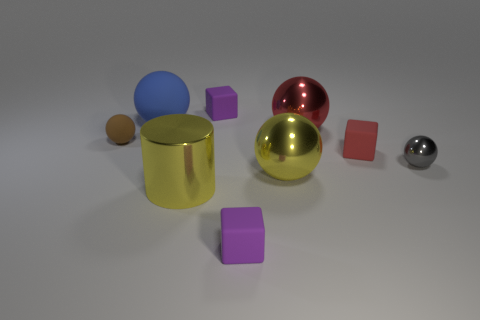Is there a tiny cyan cylinder?
Keep it short and to the point. No. How many other things are there of the same shape as the red metal thing?
Your answer should be very brief. 4. Is the color of the large thing that is on the left side of the big yellow cylinder the same as the block behind the tiny rubber sphere?
Your answer should be compact. No. There is a purple block behind the purple rubber object that is in front of the tiny gray ball behind the big yellow metal cylinder; how big is it?
Keep it short and to the point. Small. What shape is the thing that is both behind the small red matte cube and in front of the large red sphere?
Your response must be concise. Sphere. Are there an equal number of red blocks in front of the tiny brown thing and small brown balls in front of the big yellow shiny cylinder?
Make the answer very short. No. Are there any big blue balls made of the same material as the large yellow cylinder?
Your response must be concise. No. Do the purple cube that is behind the red rubber thing and the red sphere have the same material?
Offer a very short reply. No. What is the size of the matte thing that is right of the blue ball and behind the brown rubber ball?
Provide a short and direct response. Small. What is the color of the big rubber sphere?
Provide a short and direct response. Blue. 